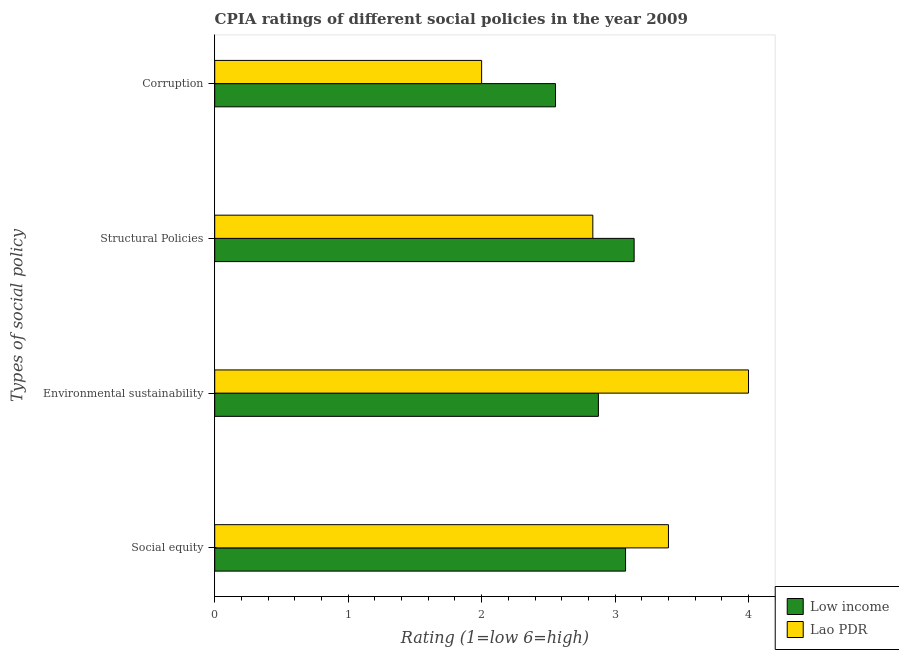How many different coloured bars are there?
Offer a terse response. 2. How many bars are there on the 2nd tick from the top?
Your answer should be compact. 2. How many bars are there on the 4th tick from the bottom?
Keep it short and to the point. 2. What is the label of the 3rd group of bars from the top?
Offer a terse response. Environmental sustainability. What is the cpia rating of environmental sustainability in Lao PDR?
Your answer should be compact. 4. Across all countries, what is the maximum cpia rating of corruption?
Offer a very short reply. 2.55. Across all countries, what is the minimum cpia rating of environmental sustainability?
Offer a very short reply. 2.88. In which country was the cpia rating of corruption minimum?
Give a very brief answer. Lao PDR. What is the total cpia rating of corruption in the graph?
Your response must be concise. 4.55. What is the difference between the cpia rating of corruption in Lao PDR and that in Low income?
Your answer should be compact. -0.55. What is the difference between the cpia rating of corruption in Low income and the cpia rating of environmental sustainability in Lao PDR?
Your answer should be compact. -1.45. What is the average cpia rating of environmental sustainability per country?
Your answer should be very brief. 3.44. What is the difference between the cpia rating of environmental sustainability and cpia rating of corruption in Low income?
Give a very brief answer. 0.32. In how many countries, is the cpia rating of structural policies greater than 3.6 ?
Ensure brevity in your answer.  0. What is the ratio of the cpia rating of environmental sustainability in Lao PDR to that in Low income?
Provide a succinct answer. 1.39. What is the difference between the highest and the second highest cpia rating of corruption?
Ensure brevity in your answer.  0.55. What is the difference between the highest and the lowest cpia rating of corruption?
Make the answer very short. 0.55. Is the sum of the cpia rating of environmental sustainability in Low income and Lao PDR greater than the maximum cpia rating of corruption across all countries?
Offer a terse response. Yes. Is it the case that in every country, the sum of the cpia rating of structural policies and cpia rating of environmental sustainability is greater than the sum of cpia rating of social equity and cpia rating of corruption?
Your answer should be very brief. Yes. What does the 2nd bar from the top in Social equity represents?
Offer a very short reply. Low income. Is it the case that in every country, the sum of the cpia rating of social equity and cpia rating of environmental sustainability is greater than the cpia rating of structural policies?
Offer a very short reply. Yes. Are all the bars in the graph horizontal?
Your answer should be compact. Yes. How many countries are there in the graph?
Your response must be concise. 2. What is the difference between two consecutive major ticks on the X-axis?
Ensure brevity in your answer.  1. Are the values on the major ticks of X-axis written in scientific E-notation?
Give a very brief answer. No. Does the graph contain any zero values?
Your response must be concise. No. What is the title of the graph?
Offer a very short reply. CPIA ratings of different social policies in the year 2009. What is the label or title of the Y-axis?
Offer a very short reply. Types of social policy. What is the Rating (1=low 6=high) in Low income in Social equity?
Provide a short and direct response. 3.08. What is the Rating (1=low 6=high) in Lao PDR in Social equity?
Keep it short and to the point. 3.4. What is the Rating (1=low 6=high) in Low income in Environmental sustainability?
Ensure brevity in your answer.  2.88. What is the Rating (1=low 6=high) of Lao PDR in Environmental sustainability?
Provide a short and direct response. 4. What is the Rating (1=low 6=high) in Low income in Structural Policies?
Your response must be concise. 3.14. What is the Rating (1=low 6=high) of Lao PDR in Structural Policies?
Give a very brief answer. 2.83. What is the Rating (1=low 6=high) in Low income in Corruption?
Provide a succinct answer. 2.55. Across all Types of social policy, what is the maximum Rating (1=low 6=high) in Low income?
Give a very brief answer. 3.14. Across all Types of social policy, what is the minimum Rating (1=low 6=high) in Low income?
Offer a terse response. 2.55. Across all Types of social policy, what is the minimum Rating (1=low 6=high) of Lao PDR?
Ensure brevity in your answer.  2. What is the total Rating (1=low 6=high) in Low income in the graph?
Provide a succinct answer. 11.65. What is the total Rating (1=low 6=high) of Lao PDR in the graph?
Ensure brevity in your answer.  12.23. What is the difference between the Rating (1=low 6=high) of Low income in Social equity and that in Environmental sustainability?
Give a very brief answer. 0.2. What is the difference between the Rating (1=low 6=high) in Lao PDR in Social equity and that in Environmental sustainability?
Your answer should be very brief. -0.6. What is the difference between the Rating (1=low 6=high) in Low income in Social equity and that in Structural Policies?
Ensure brevity in your answer.  -0.06. What is the difference between the Rating (1=low 6=high) in Lao PDR in Social equity and that in Structural Policies?
Offer a very short reply. 0.57. What is the difference between the Rating (1=low 6=high) in Low income in Social equity and that in Corruption?
Provide a short and direct response. 0.53. What is the difference between the Rating (1=low 6=high) in Lao PDR in Social equity and that in Corruption?
Your response must be concise. 1.4. What is the difference between the Rating (1=low 6=high) in Low income in Environmental sustainability and that in Structural Policies?
Ensure brevity in your answer.  -0.27. What is the difference between the Rating (1=low 6=high) in Low income in Environmental sustainability and that in Corruption?
Your answer should be very brief. 0.32. What is the difference between the Rating (1=low 6=high) of Lao PDR in Environmental sustainability and that in Corruption?
Provide a succinct answer. 2. What is the difference between the Rating (1=low 6=high) of Low income in Structural Policies and that in Corruption?
Make the answer very short. 0.59. What is the difference between the Rating (1=low 6=high) of Low income in Social equity and the Rating (1=low 6=high) of Lao PDR in Environmental sustainability?
Give a very brief answer. -0.92. What is the difference between the Rating (1=low 6=high) in Low income in Social equity and the Rating (1=low 6=high) in Lao PDR in Structural Policies?
Give a very brief answer. 0.25. What is the difference between the Rating (1=low 6=high) of Low income in Social equity and the Rating (1=low 6=high) of Lao PDR in Corruption?
Keep it short and to the point. 1.08. What is the difference between the Rating (1=low 6=high) in Low income in Environmental sustainability and the Rating (1=low 6=high) in Lao PDR in Structural Policies?
Your response must be concise. 0.04. What is the average Rating (1=low 6=high) of Low income per Types of social policy?
Provide a succinct answer. 2.91. What is the average Rating (1=low 6=high) of Lao PDR per Types of social policy?
Provide a short and direct response. 3.06. What is the difference between the Rating (1=low 6=high) of Low income and Rating (1=low 6=high) of Lao PDR in Social equity?
Your response must be concise. -0.32. What is the difference between the Rating (1=low 6=high) in Low income and Rating (1=low 6=high) in Lao PDR in Environmental sustainability?
Provide a short and direct response. -1.12. What is the difference between the Rating (1=low 6=high) of Low income and Rating (1=low 6=high) of Lao PDR in Structural Policies?
Make the answer very short. 0.31. What is the difference between the Rating (1=low 6=high) in Low income and Rating (1=low 6=high) in Lao PDR in Corruption?
Offer a terse response. 0.55. What is the ratio of the Rating (1=low 6=high) of Low income in Social equity to that in Environmental sustainability?
Make the answer very short. 1.07. What is the ratio of the Rating (1=low 6=high) in Lao PDR in Social equity to that in Environmental sustainability?
Give a very brief answer. 0.85. What is the ratio of the Rating (1=low 6=high) of Low income in Social equity to that in Structural Policies?
Offer a very short reply. 0.98. What is the ratio of the Rating (1=low 6=high) of Low income in Social equity to that in Corruption?
Your answer should be compact. 1.21. What is the ratio of the Rating (1=low 6=high) in Low income in Environmental sustainability to that in Structural Policies?
Your answer should be compact. 0.91. What is the ratio of the Rating (1=low 6=high) of Lao PDR in Environmental sustainability to that in Structural Policies?
Your answer should be compact. 1.41. What is the ratio of the Rating (1=low 6=high) of Low income in Environmental sustainability to that in Corruption?
Keep it short and to the point. 1.13. What is the ratio of the Rating (1=low 6=high) in Low income in Structural Policies to that in Corruption?
Ensure brevity in your answer.  1.23. What is the ratio of the Rating (1=low 6=high) of Lao PDR in Structural Policies to that in Corruption?
Make the answer very short. 1.42. What is the difference between the highest and the second highest Rating (1=low 6=high) of Low income?
Keep it short and to the point. 0.06. What is the difference between the highest and the second highest Rating (1=low 6=high) in Lao PDR?
Provide a succinct answer. 0.6. What is the difference between the highest and the lowest Rating (1=low 6=high) of Low income?
Your answer should be very brief. 0.59. What is the difference between the highest and the lowest Rating (1=low 6=high) in Lao PDR?
Offer a terse response. 2. 